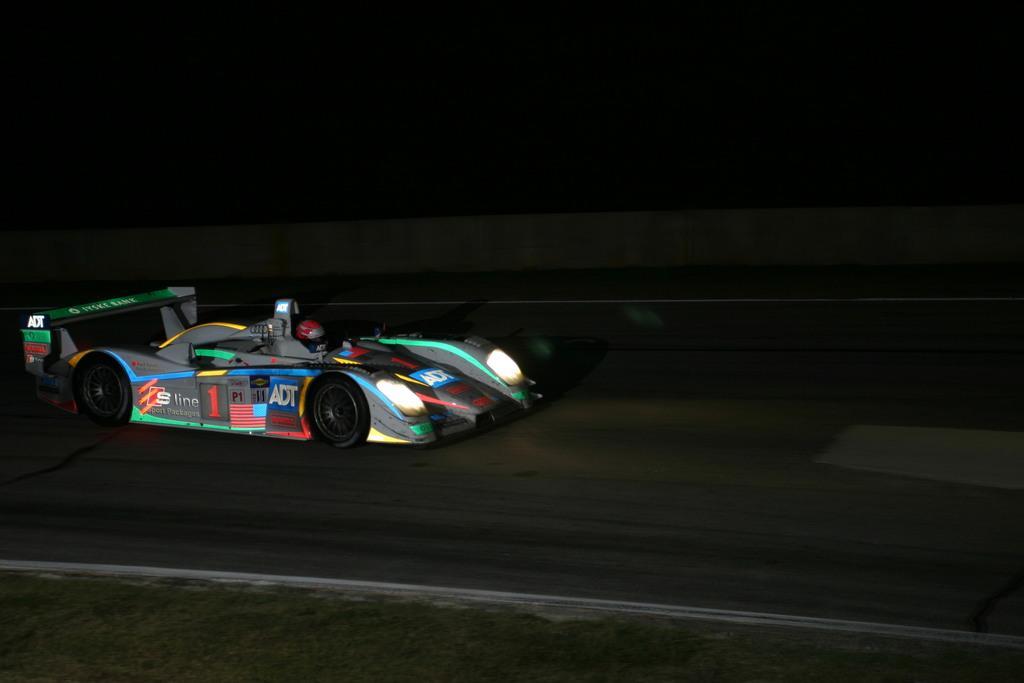Could you give a brief overview of what you see in this image? In the center of the image there is a car on the road. In the background of the image there are banners. At the bottom of the image there is grass on the surface. 